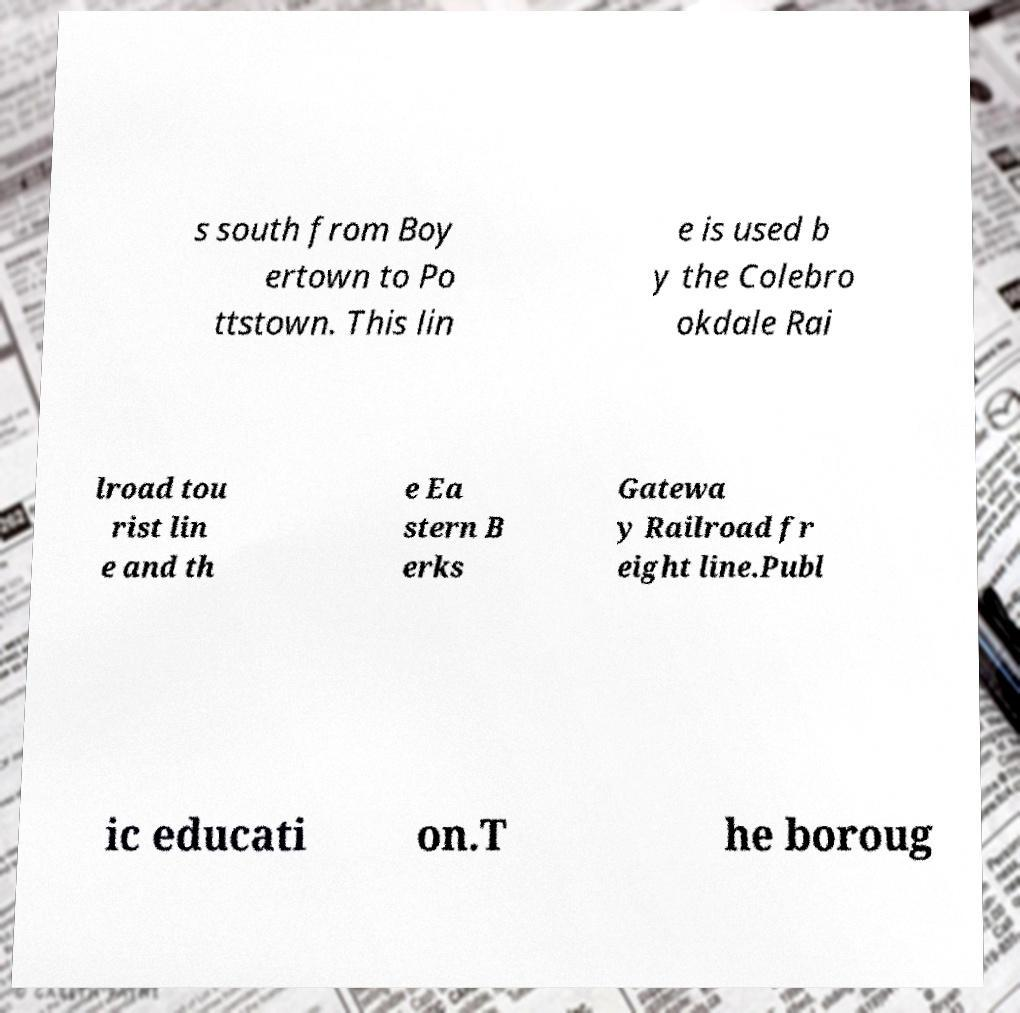Could you assist in decoding the text presented in this image and type it out clearly? s south from Boy ertown to Po ttstown. This lin e is used b y the Colebro okdale Rai lroad tou rist lin e and th e Ea stern B erks Gatewa y Railroad fr eight line.Publ ic educati on.T he boroug 